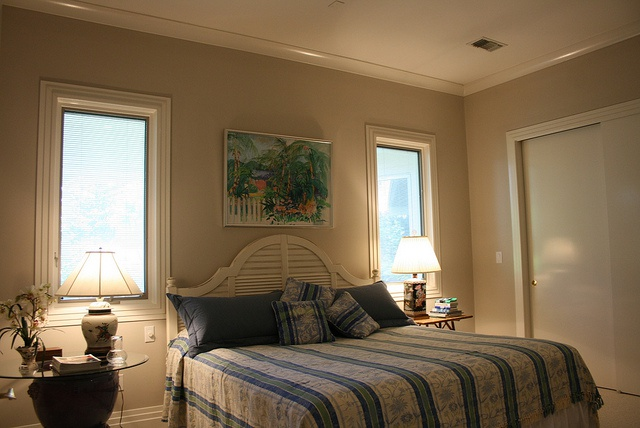Describe the objects in this image and their specific colors. I can see bed in maroon, black, and gray tones, potted plant in maroon, olive, black, tan, and gray tones, book in maroon, black, and tan tones, book in maroon, ivory, black, and tan tones, and vase in maroon, tan, and ivory tones in this image. 